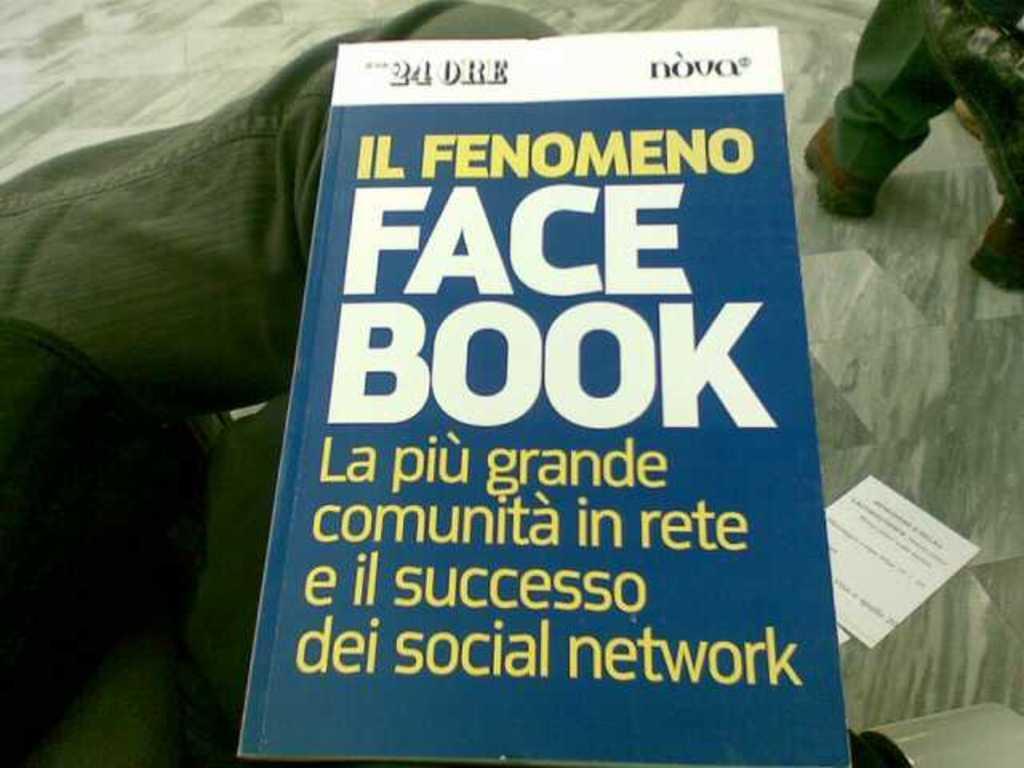Please provide a concise description of this image. In this picture we can see a book on the lap of someone. 